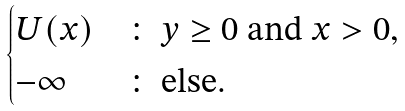<formula> <loc_0><loc_0><loc_500><loc_500>\begin{cases} U ( x ) & \colon \text { $y\geq 0$ and $x>0$} , \\ - \infty & \colon \text { else} . \end{cases}</formula> 